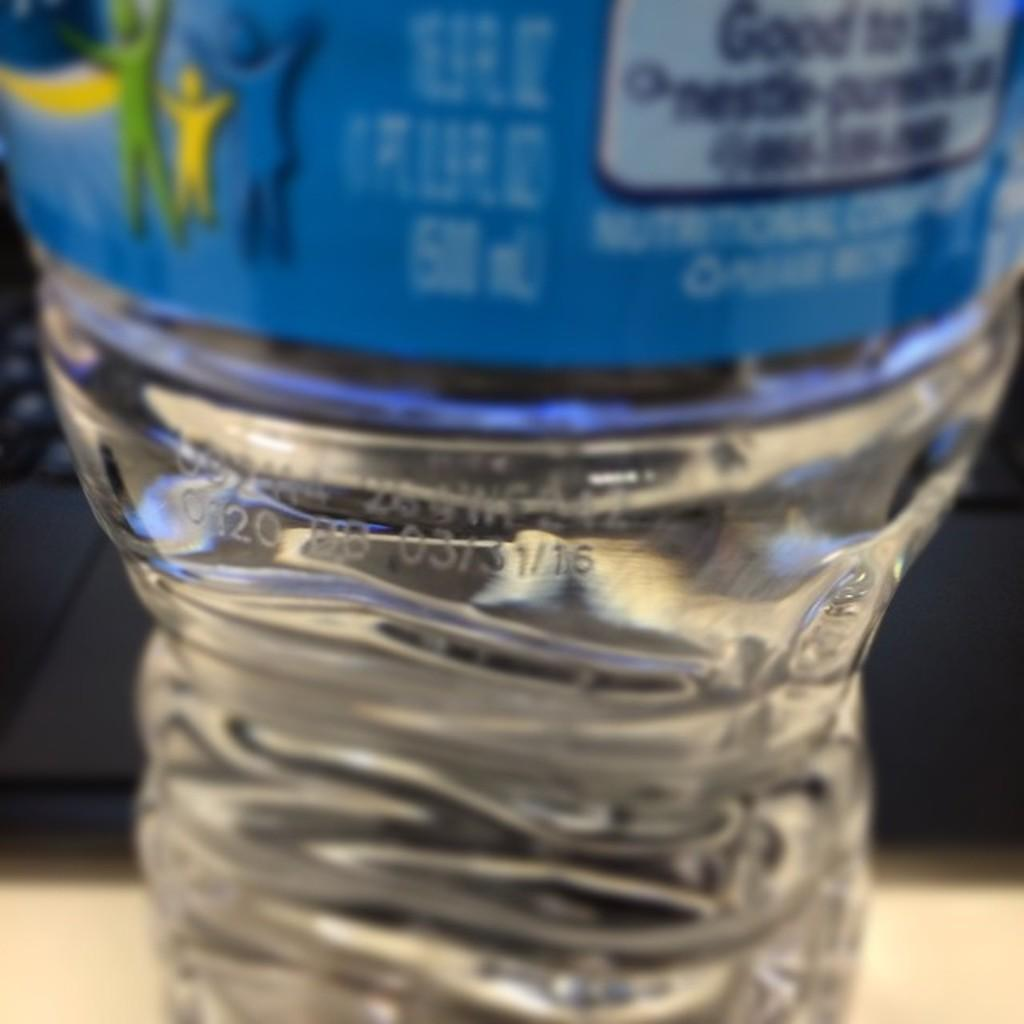What is depicted in the image? There is a picture of a water bottle in the image. What information is visible on the water bottle? The water bottle has a date and a manufacturing date on it. What else can be seen in the image besides the water bottle? There is a label in the image, and it is associated with the water bottle. What is the water bottle placed on in the image? The water bottle is placed on a table in the image. How many screws are visible on the water bottle in the image? There are no screws visible on the water bottle in the image. What stage of development is the pear in the image? There is no pear present in the image. 